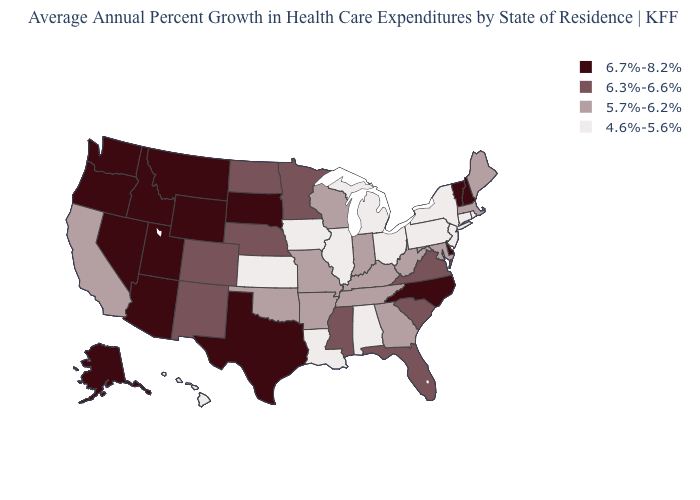What is the value of Nebraska?
Answer briefly. 6.3%-6.6%. Which states have the lowest value in the MidWest?
Answer briefly. Illinois, Iowa, Kansas, Michigan, Ohio. What is the value of Hawaii?
Be succinct. 4.6%-5.6%. What is the highest value in the MidWest ?
Quick response, please. 6.7%-8.2%. Does the first symbol in the legend represent the smallest category?
Write a very short answer. No. What is the value of Wisconsin?
Be succinct. 5.7%-6.2%. Name the states that have a value in the range 6.7%-8.2%?
Keep it brief. Alaska, Arizona, Delaware, Idaho, Montana, Nevada, New Hampshire, North Carolina, Oregon, South Dakota, Texas, Utah, Vermont, Washington, Wyoming. Which states have the highest value in the USA?
Concise answer only. Alaska, Arizona, Delaware, Idaho, Montana, Nevada, New Hampshire, North Carolina, Oregon, South Dakota, Texas, Utah, Vermont, Washington, Wyoming. Does Connecticut have the same value as Pennsylvania?
Give a very brief answer. Yes. Name the states that have a value in the range 6.3%-6.6%?
Write a very short answer. Colorado, Florida, Minnesota, Mississippi, Nebraska, New Mexico, North Dakota, South Carolina, Virginia. What is the value of Colorado?
Short answer required. 6.3%-6.6%. Among the states that border Indiana , which have the lowest value?
Concise answer only. Illinois, Michigan, Ohio. Among the states that border Texas , does Louisiana have the lowest value?
Concise answer only. Yes. Does Montana have the highest value in the USA?
Short answer required. Yes. Among the states that border Pennsylvania , does Delaware have the highest value?
Short answer required. Yes. 